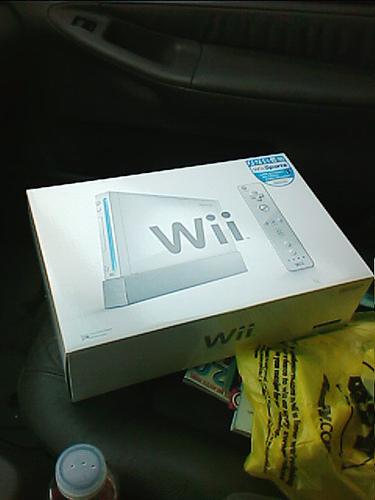Is this game system put away neatly?
Concise answer only. Yes. What video game is this?
Answer briefly. Wii. How much does it cost, according to the bag?
Keep it brief. No price. What is that white object?
Be succinct. Wii. What was purchased in the white boxes?
Give a very brief answer. Wii. Have you ever bought a device like that?
Answer briefly. Yes. Is there a Wii in the box?
Write a very short answer. Yes. What does the sign say?
Concise answer only. Wii. What language is written here?
Write a very short answer. English. What language is that?
Quick response, please. English. What model letter is printed on the box?
Concise answer only. Wii. What is in the box?
Answer briefly. Wii. 